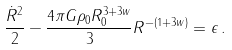Convert formula to latex. <formula><loc_0><loc_0><loc_500><loc_500>\frac { \dot { R } ^ { 2 } } { 2 } - \frac { 4 \pi G \rho _ { 0 } R _ { 0 } ^ { 3 + 3 w } } { 3 } R ^ { - ( 1 + 3 w ) } = \epsilon \, .</formula> 